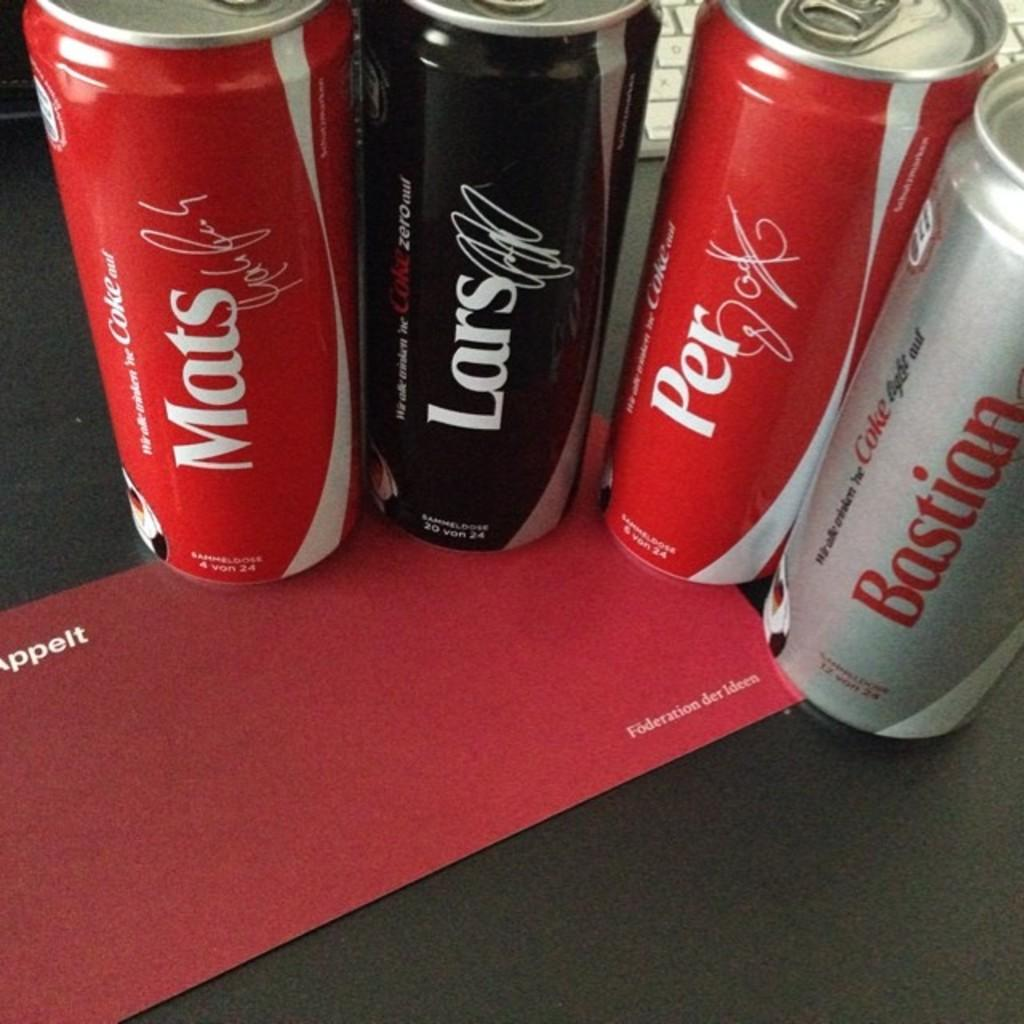<image>
Present a compact description of the photo's key features. 4 differet coke style cans that says mats lars per and bastian 